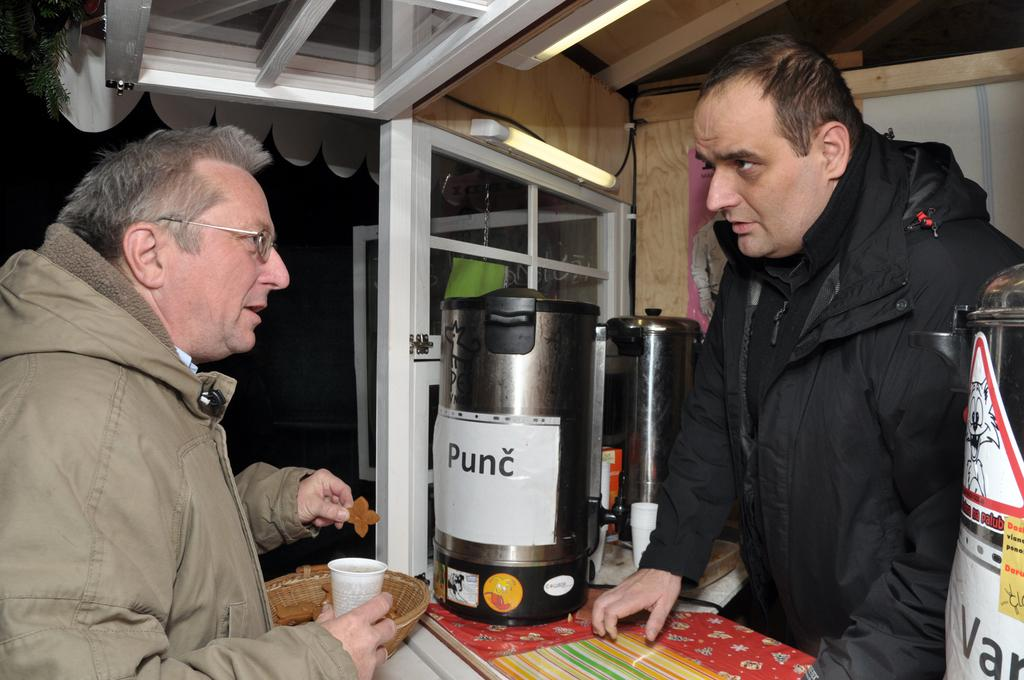<image>
Summarize the visual content of the image. A man stands in front of a drink dispenser with Punc written on it. 